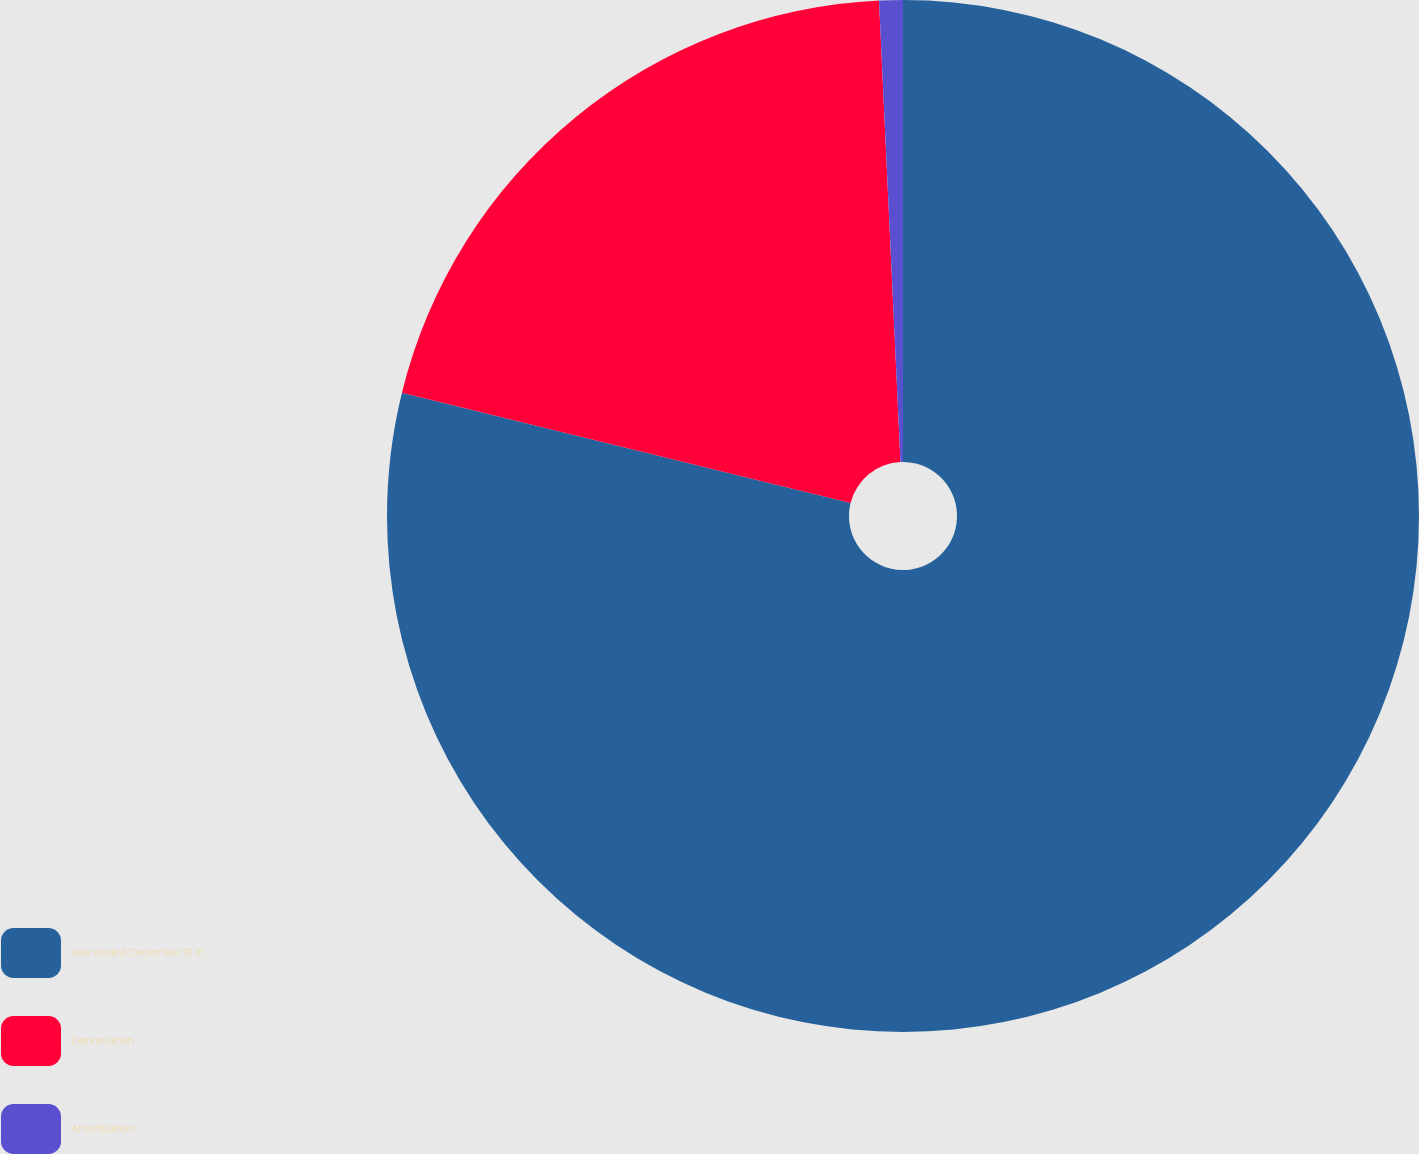<chart> <loc_0><loc_0><loc_500><loc_500><pie_chart><fcel>Year ended December 31 in<fcel>Depreciation<fcel>Amortization<nl><fcel>78.84%<fcel>20.42%<fcel>0.74%<nl></chart> 